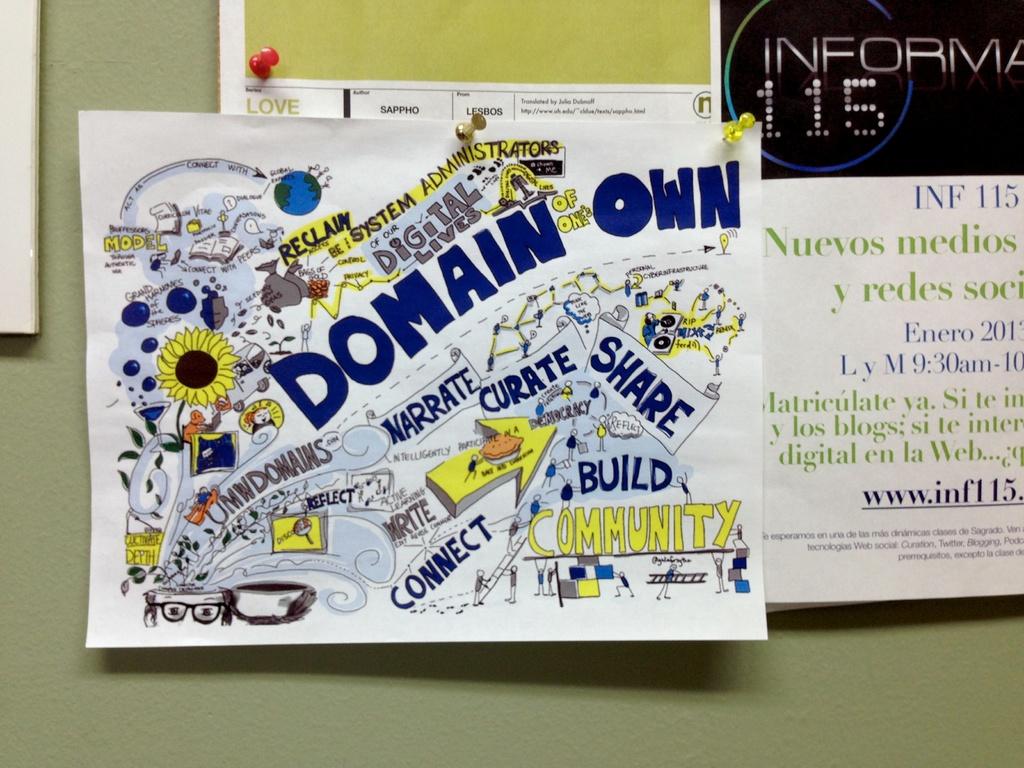What should they build?
Your response must be concise. Community. What word is written underneath the word "write"?
Give a very brief answer. Connect. 